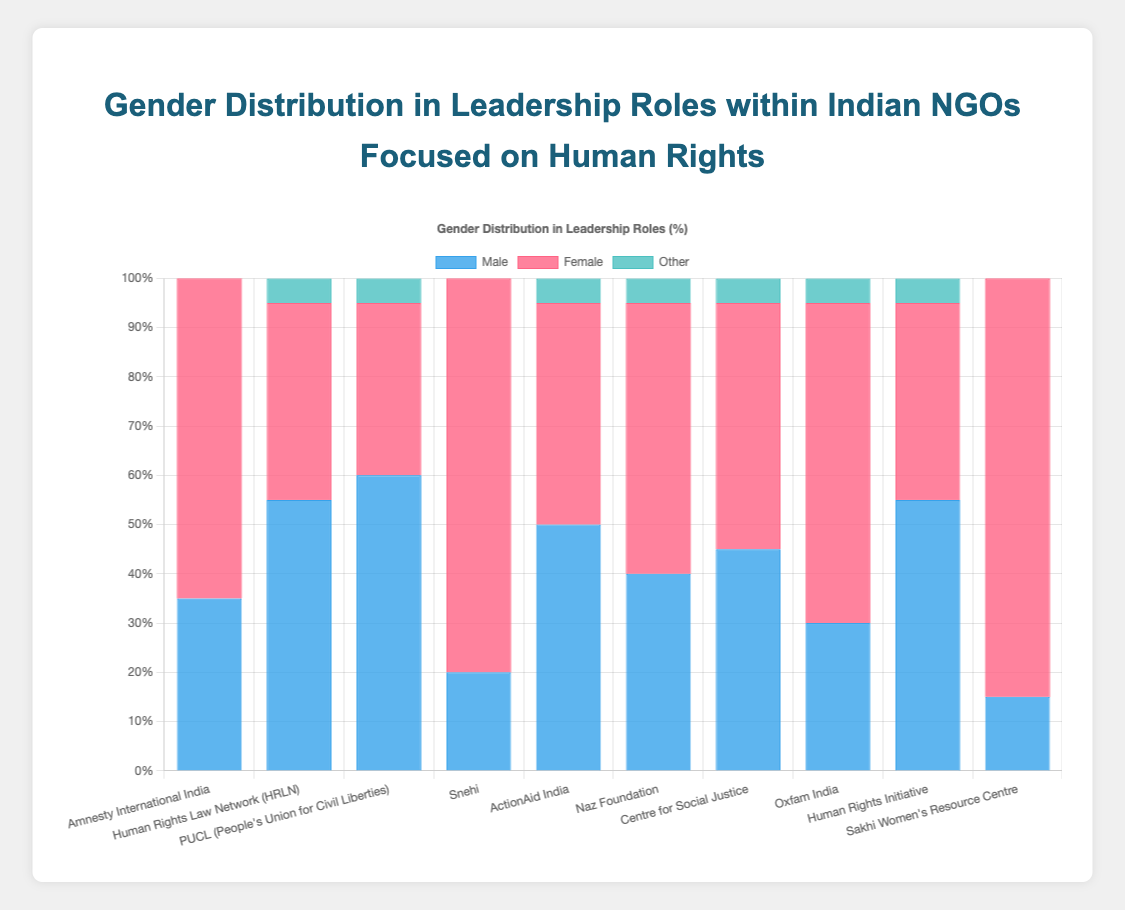Which organization has the highest percentage of female leaders? Look for the organization with the tallest red bar, which represents the female leaders. "Sakhi Women's Resource Centre" has the highest with 85%.
Answer: Sakhi Women's Resource Centre Which organization has an equal percentage of male and female leadership? Compare the length of blue and red bars for each organization. None of the organizations have equal length bars for male and female leadership.
Answer: None What is the total percentage of 'Other' leaders in the dataset? Sum the 'Other' percentages from all organizations: 0 + 5 + 5 + 0 + 5 + 5 + 5 + 5 + 5 + 0 = 35%.
Answer: 35% Which organization has the lowest percentage of male leaders? Look for the organization with the shortest blue bar. "Sakhi Women's Resource Centre" has the shortest blue bar at 15%.
Answer: Sakhi Women's Resource Centre Compare the percentage of male and female leaders in "ActionAid India". Find the blue and red bar heights for "ActionAid India". The male leaders are at 50% and female leaders are at 45%.
Answer: Male: 50%, Female: 45% What is the combined percentage of male and female leaders in "Naz Foundation"? Add the male and female percentages for "Naz Foundation". 40% (Male) + 55% (Female) = 95%.
Answer: 95% How many organizations have more female than male leaders? Count the organizations where the red bar (female leaders) is taller than the blue bar (male leaders): 5 organizations (Amnesty International India, Snehi, Naz Foundation, Oxfam India, Sakhi Women's Resource Centre).
Answer: 5 Which organization has the highest percentage of 'Other' leaders? Compare the height of the green bars for each organization. Several organizations have the highest percentage of 'Other' leaders at 5% each (HRLN, PUCL, ActionAid India, Naz Foundation, Centre for Social Justice, Oxfam India, Human Rights Initiative).
Answer: HRLN, PUCL, ActionAid India, Naz Foundation, Centre for Social Justice, Oxfam India, Human Rights Initiative What is the difference in the percentage of male leaders between "Human Rights Law Network (HRLN)" and "Sakhi Women's Resource Centre"? Subtract the percentage of male leaders in "Sakhi Women's Resource Centre" from "Human Rights Law Network (HRLN)". 55% (HRLN) - 15% (Sakhi Women's Resource Centre) = 40%.
Answer: 40% Identify the organization which has exactly 5% 'Other' leaders and 45% female leaders. Check the organizations with green bars at 5% and find which one has a red bar at 45%. "ActionAid India" matches this description.
Answer: ActionAid India 